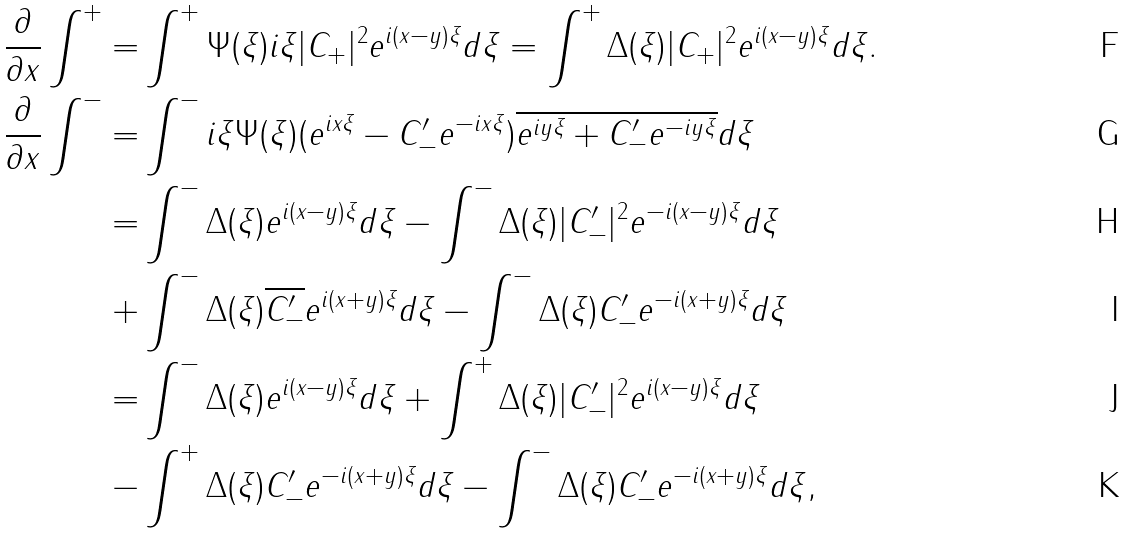<formula> <loc_0><loc_0><loc_500><loc_500>\frac { \partial } { \partial x } \int ^ { + } = & \int ^ { + } \Psi ( \xi ) i \xi | C _ { + } | ^ { 2 } e ^ { i ( x - y ) \xi } d \xi = \int ^ { + } \Delta ( \xi ) | C _ { + } | ^ { 2 } e ^ { i ( x - y ) \xi } d \xi . \\ \frac { \partial } { \partial x } \int ^ { - } = & \int ^ { - } i \xi \Psi ( \xi ) ( e ^ { i x \xi } - C ^ { \prime } _ { - } e ^ { - i x \xi } ) \overline { e ^ { i y \xi } + C ^ { \prime } _ { - } e ^ { - i y \xi } } d \xi \\ = & \int ^ { - } \Delta ( \xi ) e ^ { i ( x - y ) \xi } d \xi - \int ^ { - } \Delta ( \xi ) | C ^ { \prime } _ { - } | ^ { 2 } e ^ { - i ( x - y ) \xi } d \xi \\ + & \int ^ { - } \Delta ( \xi ) \overline { C ^ { \prime } _ { - } } e ^ { i ( x + y ) \xi } d \xi - \int ^ { - } \Delta ( \xi ) C ^ { \prime } _ { - } e ^ { - i ( x + y ) \xi } d \xi \\ = & \int ^ { - } \Delta ( \xi ) e ^ { i ( x - y ) \xi } d \xi + \int ^ { + } \Delta ( \xi ) | C ^ { \prime } _ { - } | ^ { 2 } e ^ { i ( x - y ) \xi } d \xi \\ - & \int ^ { + } \Delta ( \xi ) C ^ { \prime } _ { - } e ^ { - i ( x + y ) \xi } d \xi - \int ^ { - } \Delta ( \xi ) C ^ { \prime } _ { - } e ^ { - i ( x + y ) \xi } d \xi ,</formula> 